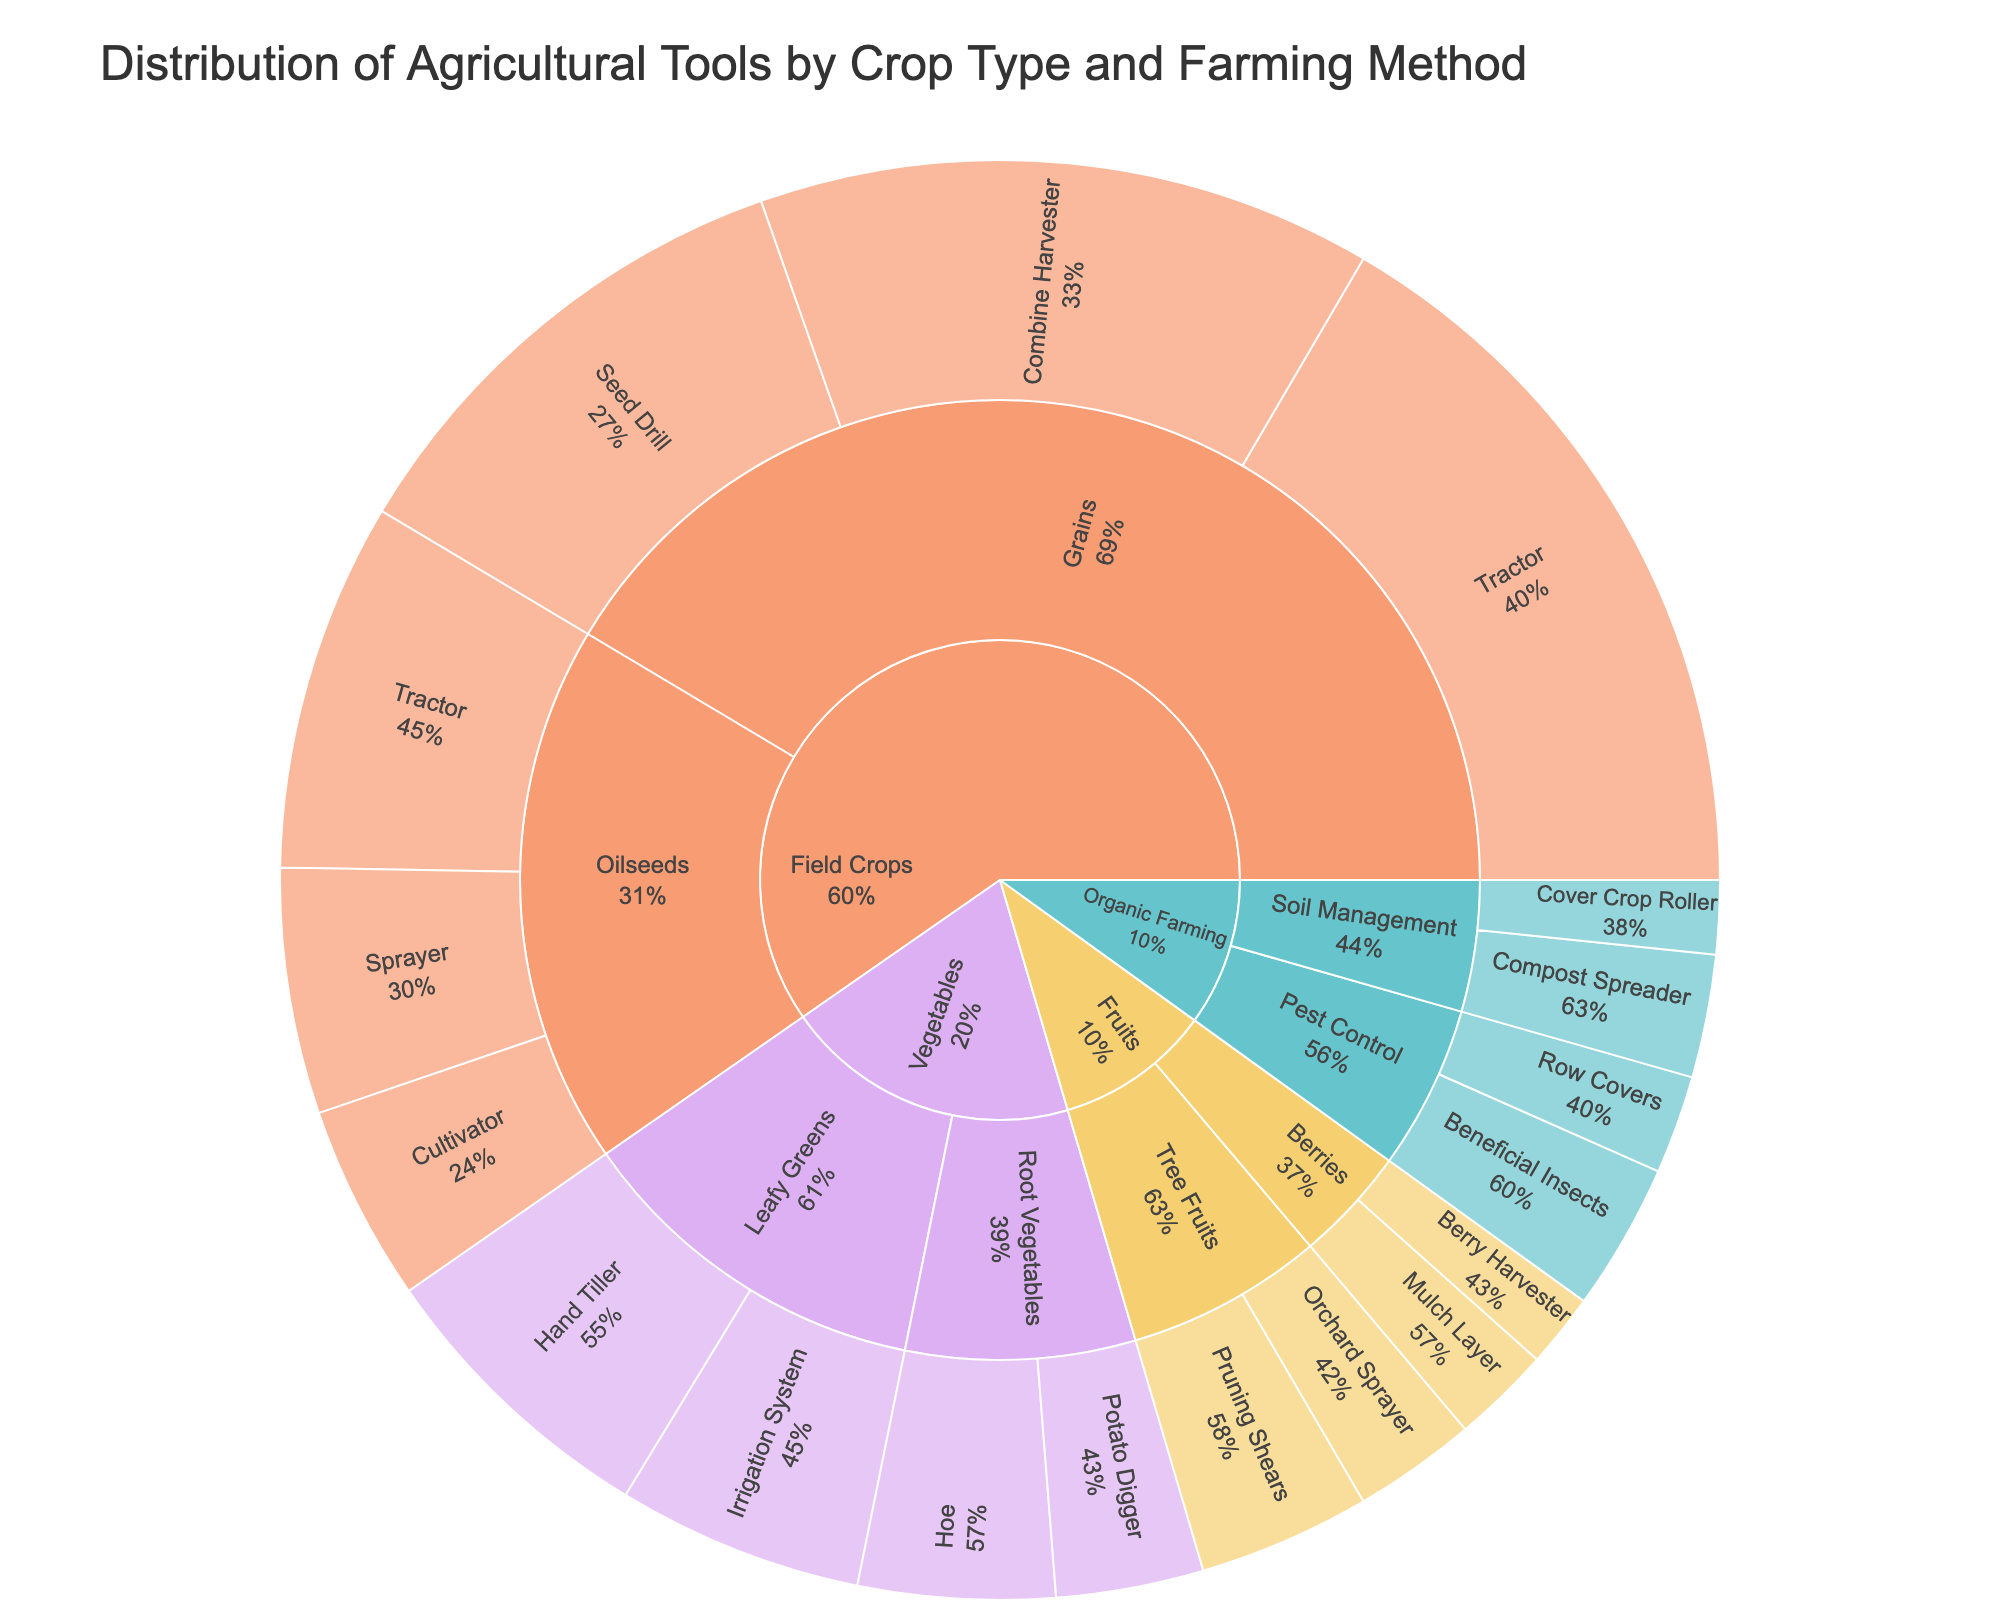What is the title of the Sunburst Plot? The title of the Sunburst Plot is displayed at the top and it summarizes the subject of the plot.
Answer: Distribution of Agricultural Tools by Crop Type and Farming Method Which crop type has the most variety of tools represented? Inspect the plot and count the different tools associated with each main crop category to find out which has the most variety.
Answer: Field Crops What percentage of the 'Grains' subcategory is made up by Tractors? Locate 'Grains' under 'Field Crops' and find the percentage that the 'Tractor' occupies in this specific subcategory. According to the figure, it is given directly.
Answer: 33% How many tools are related to 'Organic Farming'? Look for the 'Organic Farming' section and count the total number of tools shown in that segment of the plot.
Answer: 4 Which tool has the highest value under 'Vegetables'? Under 'Vegetables', compare the values of the tools for both 'Leafy Greens' and 'Root Vegetables' to determine which tool has the highest value.
Answer: Hand Tiller Which farming method subcategory has an equal number of tools as 'Tree Fruits' under 'Fruits'? First, identify the number of tools in 'Tree Fruits', which is 2. Then find the farming method subcategory that also has 2 tools.
Answer: Soil Management (Organic Farming) Are there more tools related to 'Pest Control' or 'Berries'? Count the tools under 'Pest Control' and 'Berries' and compare the two totals to determine which has more tools.
Answer: Pest Control What is the combined value of tools for 'Field Crops'? Sum up the values of all tools listed under 'Field Crops' for a combined total. Calculation: (30+25+20+15+10+8) = 108
Answer: 108 Which subcategory has the least total value, and what is it? Compare the total values for each subcategory by summing the value of tools within them to find the one with the least total value. 'Berries' has a total value of (4+3) = 7.
Answer: Berries, 7 